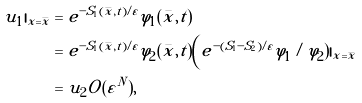<formula> <loc_0><loc_0><loc_500><loc_500>u _ { 1 } | _ { x = \bar { x } } & = e ^ { - S _ { 1 } ( \bar { x } , t ) / \varepsilon } \varphi _ { 1 } ( \bar { x } , t ) \\ & = e ^ { - S _ { 1 } ( \bar { x } , t ) / \varepsilon } \varphi _ { 2 } ( \bar { x } , t ) \Big ( e ^ { - ( S _ { 1 } - S _ { 2 } ) / \varepsilon } \varphi _ { 1 } / \varphi _ { 2 } ) | _ { x = \bar { x } } \\ & = u _ { 2 } O ( \varepsilon ^ { N } ) ,</formula> 